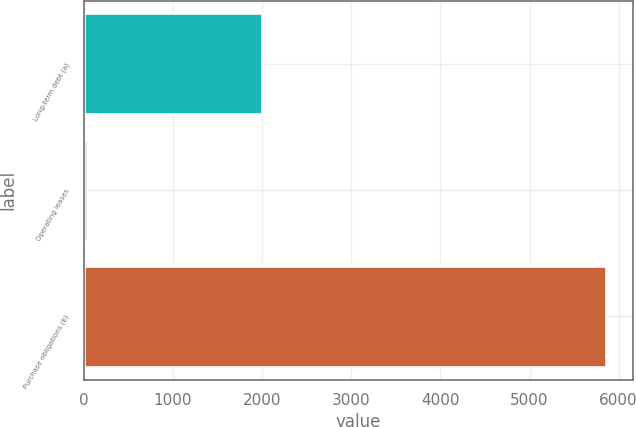<chart> <loc_0><loc_0><loc_500><loc_500><bar_chart><fcel>Long-term debt (a)<fcel>Operating leases<fcel>Purchase obligations (b)<nl><fcel>1994<fcel>38<fcel>5863<nl></chart> 